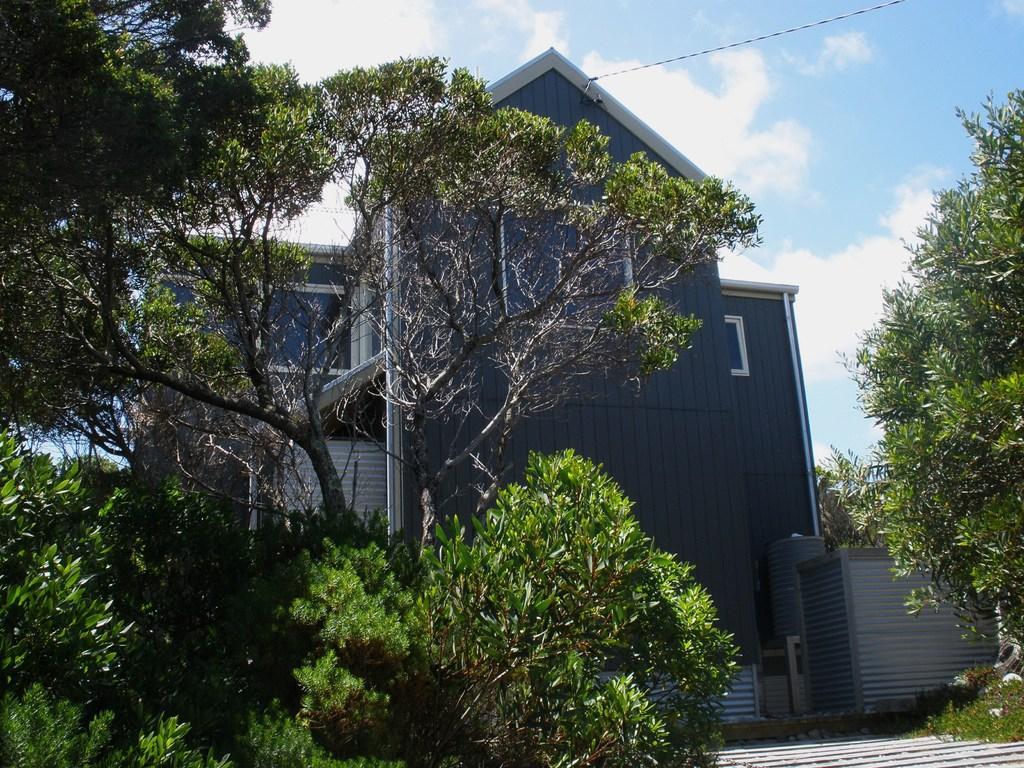What type of vegetation can be seen in the image? There are trees in the image. What type of structure is present in the image? There is a building in the image. What can be seen in the background of the image? The sky with clouds is visible in the background of the image. What is located at the top of the image? There is a wire at the top of the image. How many bones can be seen in the image? There are no bones present in the image. What is the profit of the building in the image? The image does not provide information about the profit of the building. 